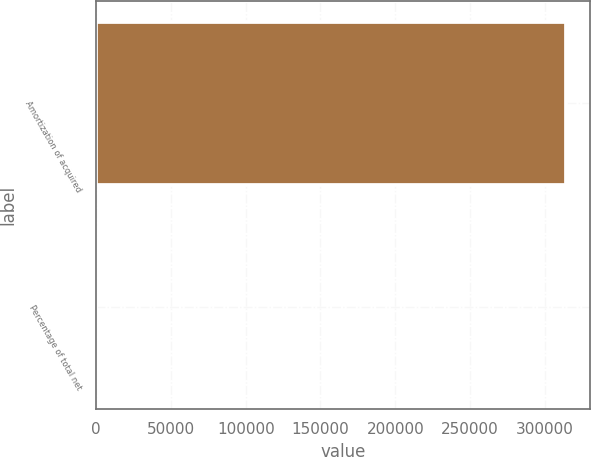<chart> <loc_0><loc_0><loc_500><loc_500><bar_chart><fcel>Amortization of acquired<fcel>Percentage of total net<nl><fcel>314290<fcel>8<nl></chart> 